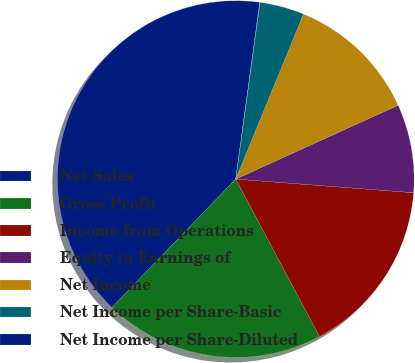Convert chart. <chart><loc_0><loc_0><loc_500><loc_500><pie_chart><fcel>Net Sales<fcel>Gross Profit<fcel>Income from Operations<fcel>Equity in Earnings of<fcel>Net Income<fcel>Net Income per Share-Basic<fcel>Net Income per Share-Diluted<nl><fcel>39.94%<fcel>19.99%<fcel>16.0%<fcel>8.01%<fcel>12.01%<fcel>4.02%<fcel>0.03%<nl></chart> 